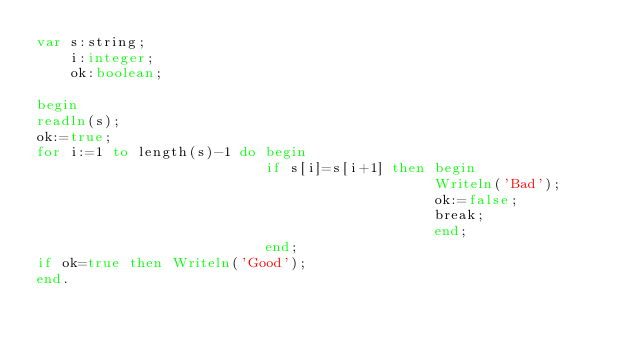Convert code to text. <code><loc_0><loc_0><loc_500><loc_500><_Pascal_>var s:string;
    i:integer;
    ok:boolean; 

begin
readln(s);
ok:=true;
for i:=1 to length(s)-1 do begin
                           if s[i]=s[i+1] then begin
                                               Writeln('Bad');
                                               ok:=false; 
                                               break;
                                               end;
                           end;
if ok=true then Writeln('Good');
end.</code> 